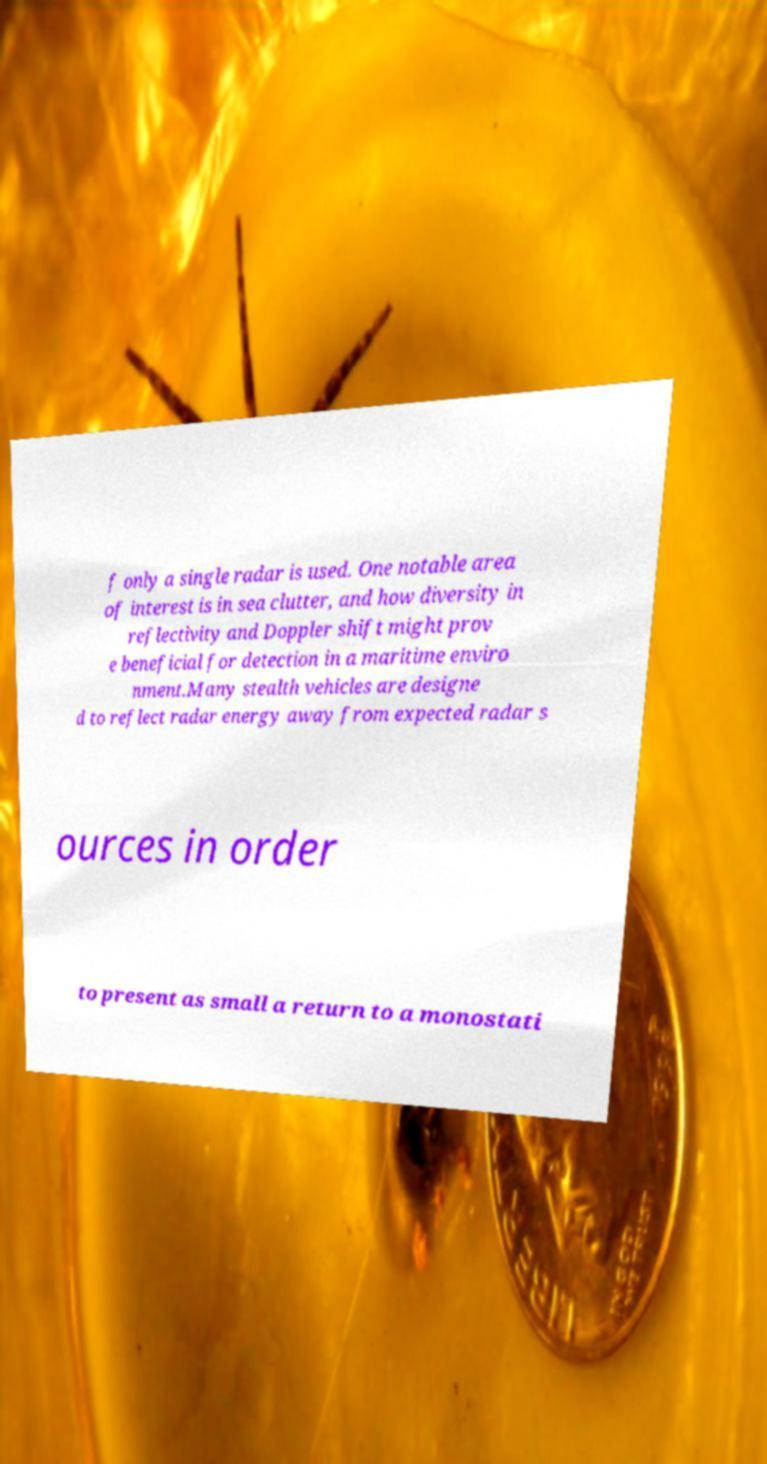For documentation purposes, I need the text within this image transcribed. Could you provide that? f only a single radar is used. One notable area of interest is in sea clutter, and how diversity in reflectivity and Doppler shift might prov e beneficial for detection in a maritime enviro nment.Many stealth vehicles are designe d to reflect radar energy away from expected radar s ources in order to present as small a return to a monostati 